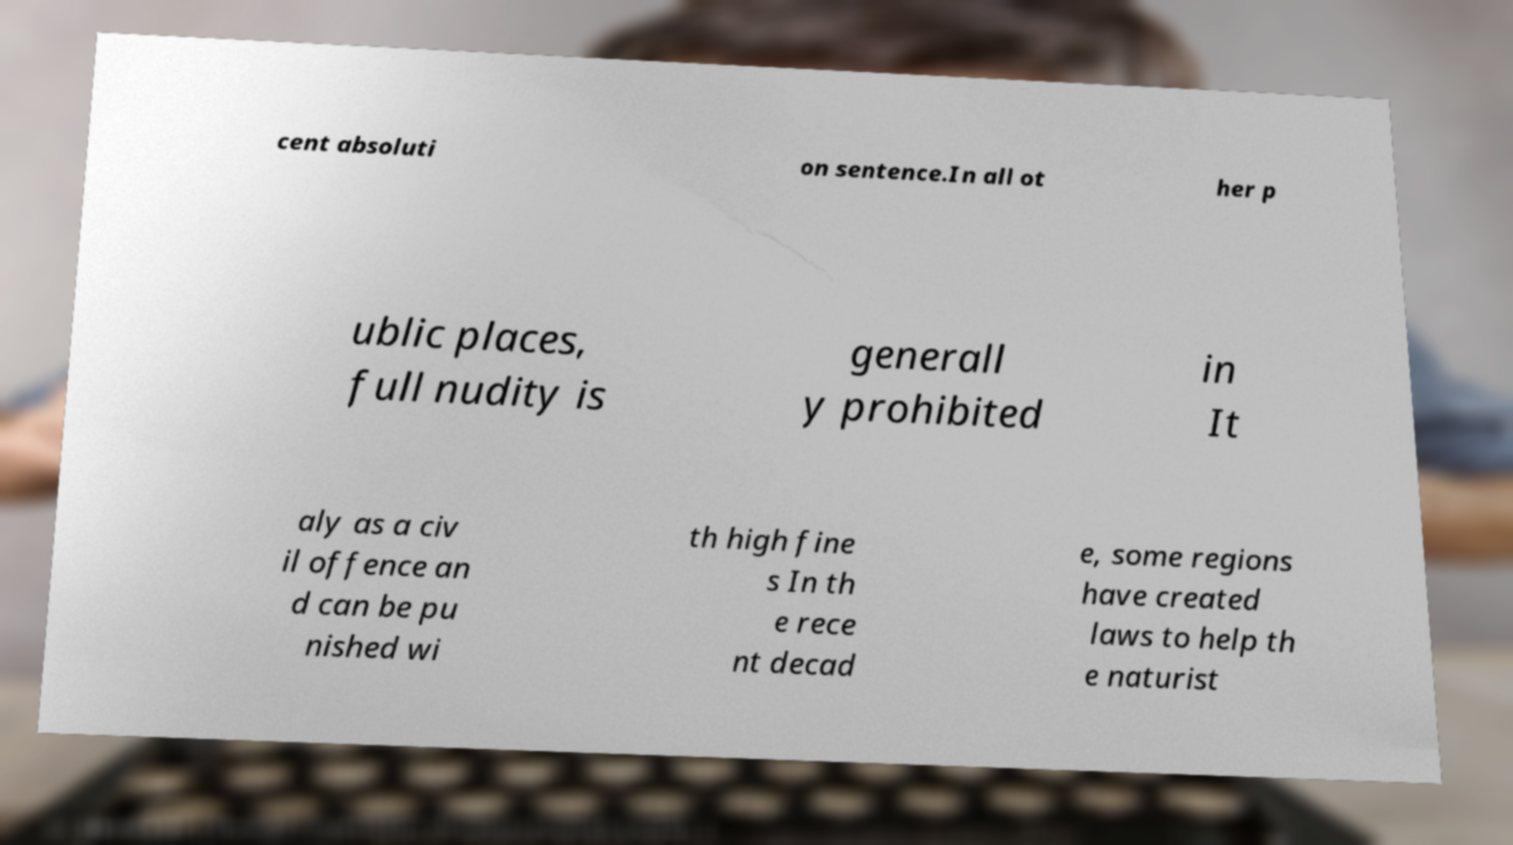Could you assist in decoding the text presented in this image and type it out clearly? cent absoluti on sentence.In all ot her p ublic places, full nudity is generall y prohibited in It aly as a civ il offence an d can be pu nished wi th high fine s In th e rece nt decad e, some regions have created laws to help th e naturist 